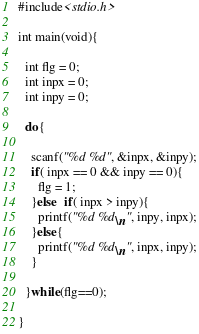<code> <loc_0><loc_0><loc_500><loc_500><_C++_>#include<stdio.h>
 
int main(void){
 
  int flg = 0;
  int inpx = 0;
  int inpy = 0;
 
  do{
     
    scanf("%d %d", &inpx, &inpy);
    if( inpx == 0 && inpy == 0){
      flg = 1;
    }else  if( inpx > inpy){
      printf("%d %d\n", inpy, inpx);
    }else{
      printf("%d %d\n", inpx, inpy);
    }
 
  }while(flg==0);
 
}</code> 